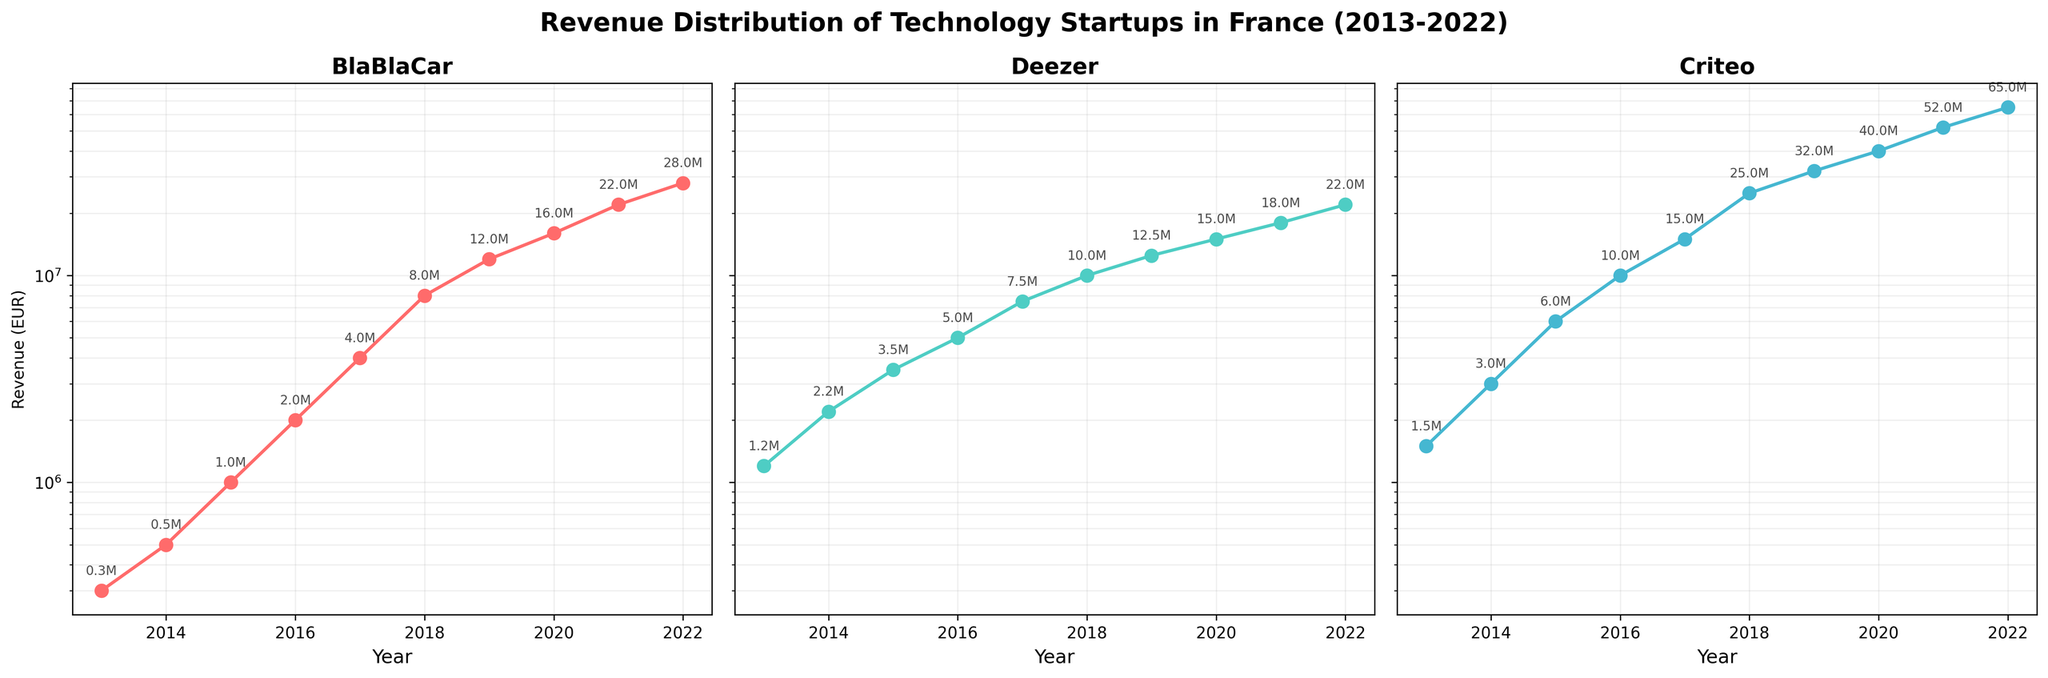What is the overall trend of BlaBlaCar's revenue from 2013 to 2022? BlaBlaCar’s revenue shows a clear upward trend from 2013 to 2022, with values increasing from 300,000 EUR in 2013 to 28,000,000 EUR in 2022.
Answer: Upward trend Which company had the highest revenue in 2022? By looking at the ending revenue figures for 2022 in each subplot, Criteo had the highest revenue at 65,000,000 EUR.
Answer: Criteo Which year did Deezer’s revenue first exceed 10 million EUR? From the plot, Deezer’s revenue exceeds 10 million EUR in 2018, where it is shown to reach exactly that mark.
Answer: 2018 How does Criteo's revenue growth compare to BlaBlaCar's over the last decade? Criteo’s revenue starts higher and grows more steeply compared to BlaBlaCar’s. By 2022, Criteo's revenues reached 65,000,000 EUR while BlaBlaCar's reached 28,000,000 EUR.
Answer: Criteo’s growth is steeper What was BlaBlaCar's revenue in 2016 and how does it compare to its revenue in 2013? In 2016, BlaBlaCar’s revenue was 2,000,000 EUR, which is significantly higher compared to 300,000 EUR in 2013.
Answer: 2,000,000 EUR in 2016, compared to 300,000 EUR in 2013 Which company has shown the most consistent revenue growth according to the plots? BlaBlaCar shows the most consistent revenue growth with a smoother and more predictable upward trend each year.
Answer: BlaBlaCar What was the percentage increase in revenue from 2013 to 2022 for Deezer? Deezer’s revenue increased from 1,200,000 EUR in 2013 to 22,000,000 EUR in 2022. The percentage increase can be calculated as ((22,000,000 - 1,200,000) / 1,200,000) * 100 = 1,733.33%.
Answer: 1,733.33% Between BlaBlaCar and Deezer, which company had a higher revenue in 2017? In 2017, Deezer's revenue was 7,500,000 EUR whereas BlaBlaCar's revenue was 4,000,000 EUR. Thus, Deezer had a higher revenue.
Answer: Deezer Describe the changes in Criteo’s revenue from 2015 to 2016. Criteo's revenue doubled from 6,000,000 EUR in 2015 to 10,000,000 EUR in 2016, which indicates rapid growth during that period.
Answer: Doubled In which years did all three companies' revenues exceed 10 million EUR? From examining the plots, in 2019, 2020, 2021, and 2022, all three companies’ revenues were above 10 million EUR.
Answer: 2019, 2020, 2021, 2022 